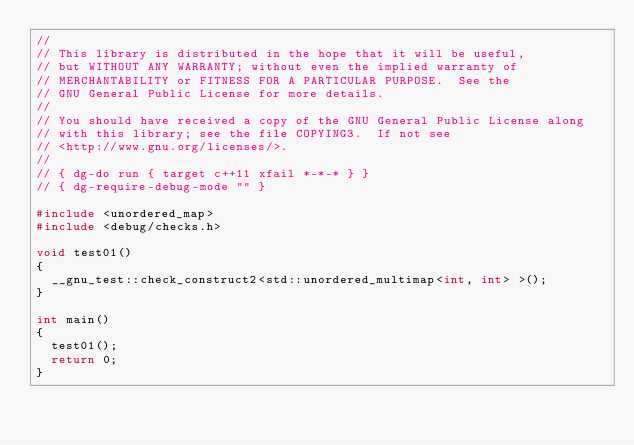<code> <loc_0><loc_0><loc_500><loc_500><_C++_>//
// This library is distributed in the hope that it will be useful,
// but WITHOUT ANY WARRANTY; without even the implied warranty of
// MERCHANTABILITY or FITNESS FOR A PARTICULAR PURPOSE.  See the
// GNU General Public License for more details.
//
// You should have received a copy of the GNU General Public License along
// with this library; see the file COPYING3.  If not see
// <http://www.gnu.org/licenses/>.
//
// { dg-do run { target c++11 xfail *-*-* } }
// { dg-require-debug-mode "" }

#include <unordered_map>
#include <debug/checks.h>

void test01()
{
  __gnu_test::check_construct2<std::unordered_multimap<int, int> >();
}

int main()
{
  test01();
  return 0;
}
</code> 